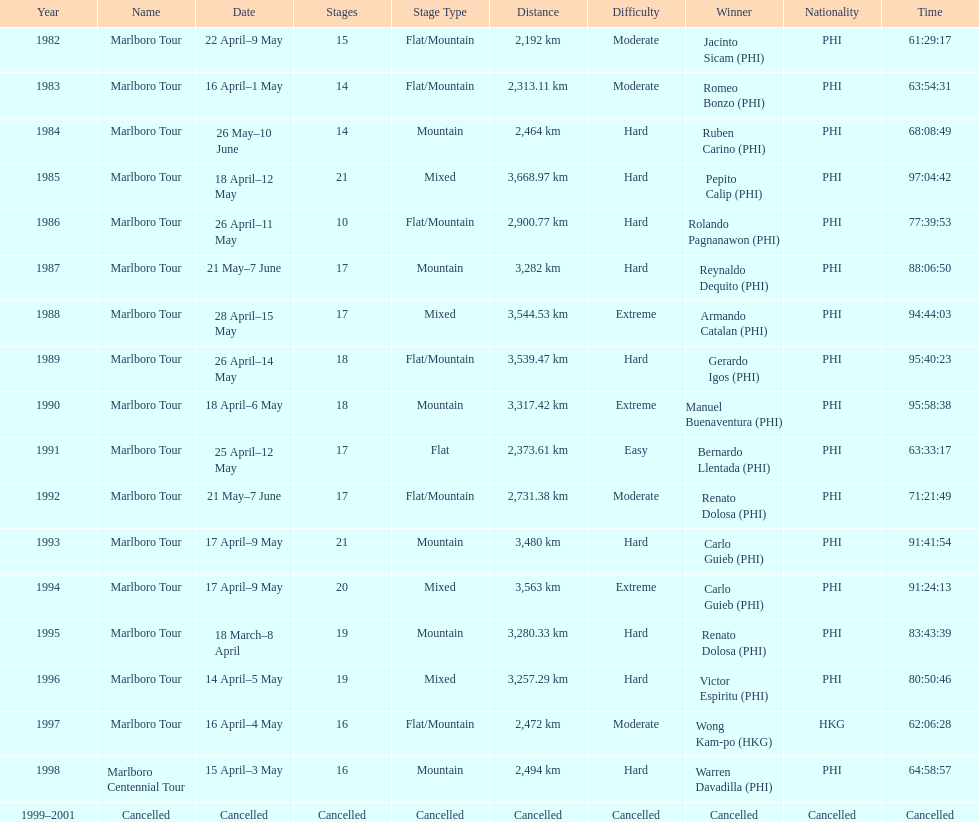How long did it take warren davadilla to complete the 1998 marlboro centennial tour? 64:58:57. 